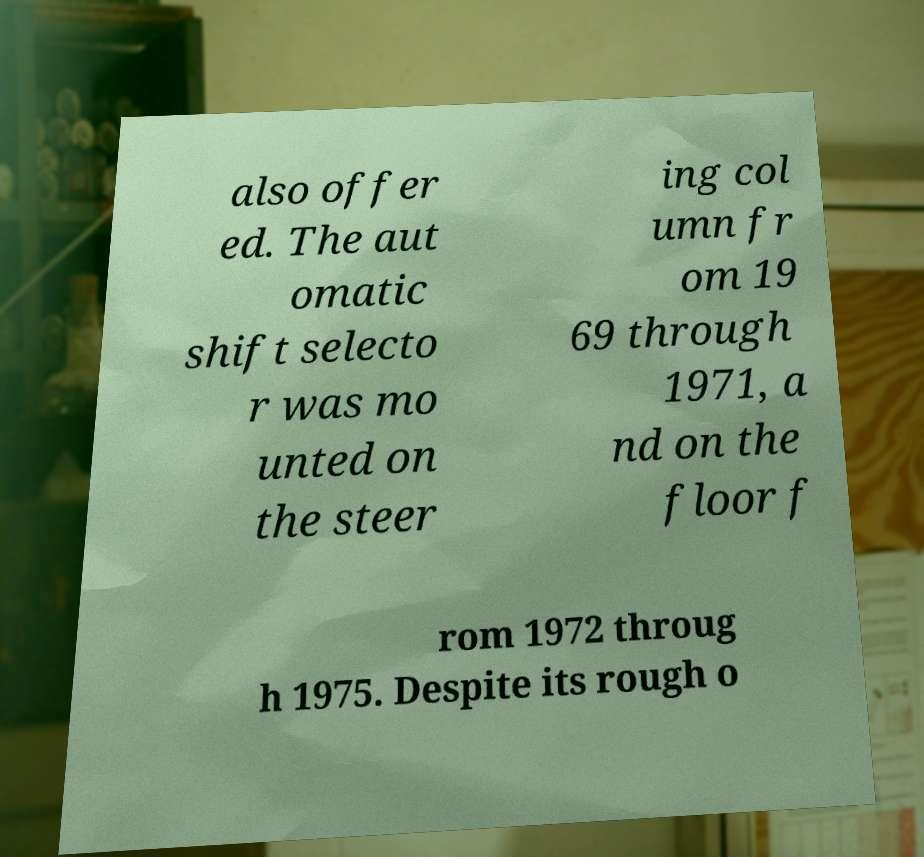Can you accurately transcribe the text from the provided image for me? also offer ed. The aut omatic shift selecto r was mo unted on the steer ing col umn fr om 19 69 through 1971, a nd on the floor f rom 1972 throug h 1975. Despite its rough o 